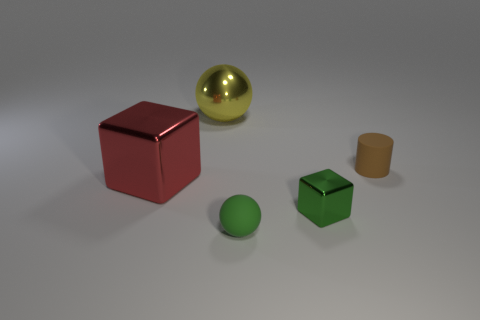Add 2 big cubes. How many objects exist? 7 Subtract all balls. How many objects are left? 3 Subtract all red cubes. Subtract all small green metal blocks. How many objects are left? 3 Add 5 red metallic blocks. How many red metallic blocks are left? 6 Add 3 big metallic spheres. How many big metallic spheres exist? 4 Subtract 0 purple spheres. How many objects are left? 5 